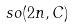<formula> <loc_0><loc_0><loc_500><loc_500>s o ( 2 n , C )</formula> 